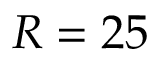<formula> <loc_0><loc_0><loc_500><loc_500>R = 2 5</formula> 